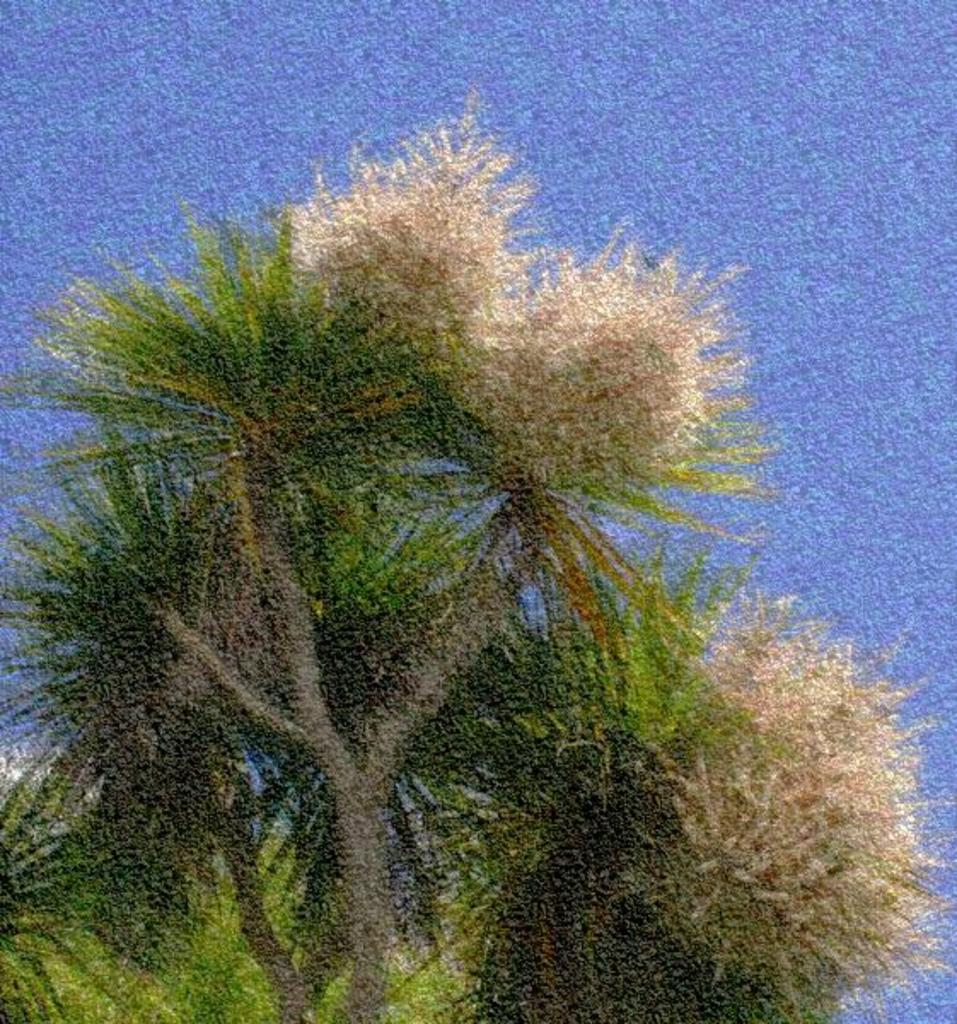What type of plant can be seen in the image? There is a tree in the image. What color is the background of the image? The background of the image is blue. How many pigs are visible in the image? There are no pigs present in the image. What type of geological feature can be seen in the image? There is no geological feature mentioned in the provided facts. Is there a bridge visible in the image? There is no bridge mentioned in the provided facts. 